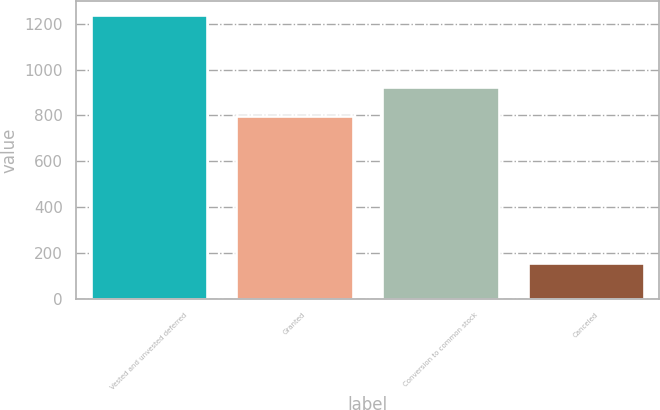Convert chart to OTSL. <chart><loc_0><loc_0><loc_500><loc_500><bar_chart><fcel>Vested and unvested deferred<fcel>Granted<fcel>Conversion to common stock<fcel>Canceled<nl><fcel>1237<fcel>797<fcel>925.7<fcel>153<nl></chart> 